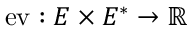<formula> <loc_0><loc_0><loc_500><loc_500>{ e v } \colon E \times E ^ { * } \to \mathbb { R }</formula> 